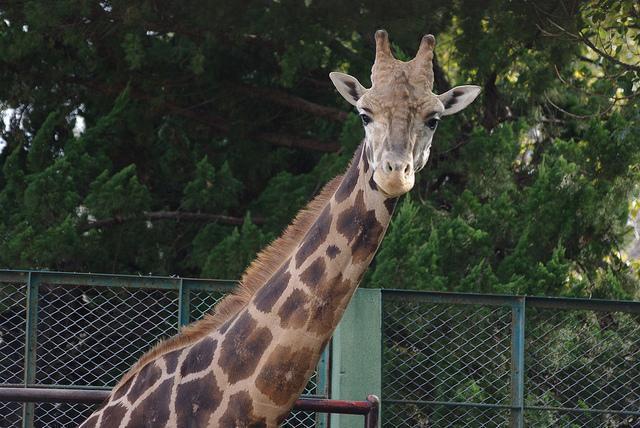How many giraffes are there?
Give a very brief answer. 1. 